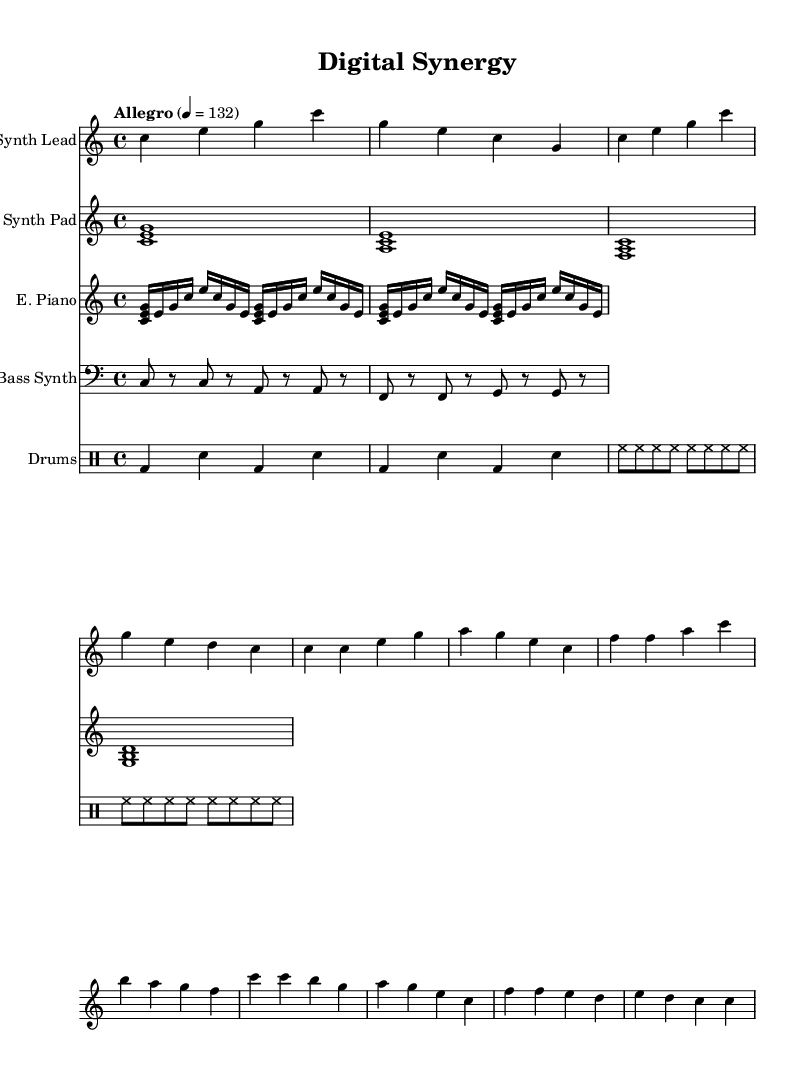What is the key signature of this music? The key signature is C major, which has no sharps or flats.
Answer: C major What is the time signature of this music? The time signature is indicated at the beginning of the score as 4/4, meaning there are four beats per measure.
Answer: 4/4 What is the tempo marking of the piece? The tempo marking indicates how fast the piece should be played, noted as "Allegro" and a metronome marking of 132 beats per minute.
Answer: Allegro, 132 What is the main rhythmic style of the drums? The drum part illustrates a "four-on-the-floor" style, characterized by a kick drum on every beat and snare accents on the 2nd and 4th beats.
Answer: Four-on-the-floor How many different instruments are specified in the score? The score features five distinct instruments: Synth Lead, Synth Pad, Electric Piano, Bass Synth, and Drums.
Answer: Five In the synth lead, how many measures are there in the chorus section? By analyzing the notation provided, there are four measures in the chorus section of the synth lead.
Answer: Four What type of harmony is used in the synth pad? The synth pad features sustained chords which create a harmonic foundation, illustrating a static harmonic style typical for soundtracks.
Answer: Sustained chords 